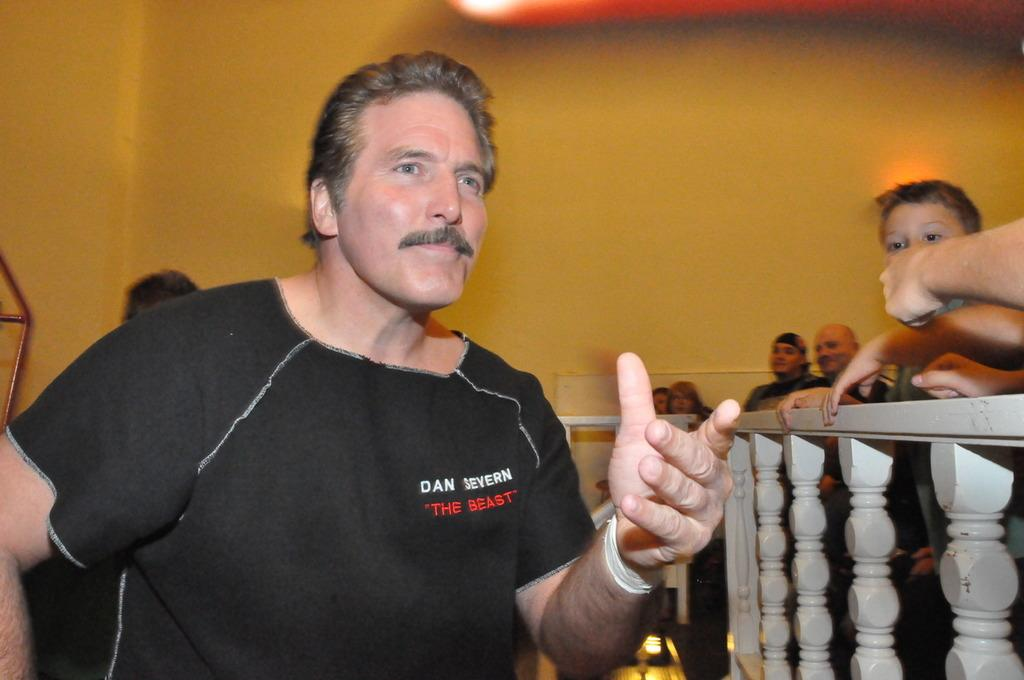What is the person in the image wearing? The person in the image is wearing a black t-shirt. Where is the person standing in relation to the fence? The person is standing beside the fence. Can you describe the people visible on the other side of the fence? Unfortunately, the facts provided do not give any information about the people on the other side of the fence. What type of throne is the person sitting on in the image? There is no throne present in the image; the person is standing beside a fence. 